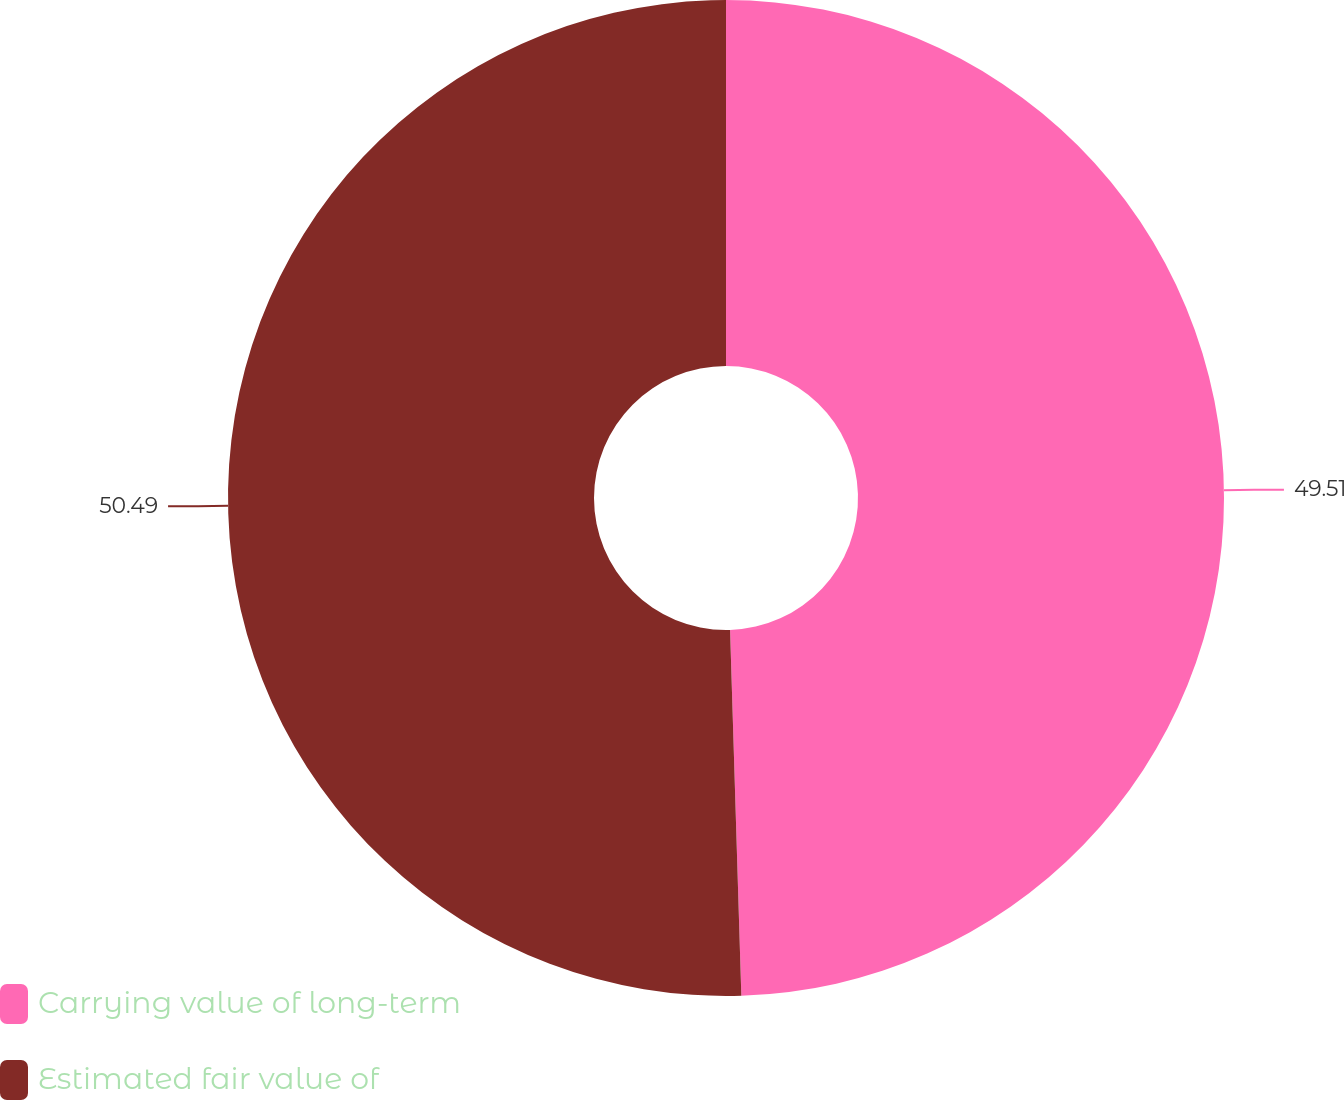<chart> <loc_0><loc_0><loc_500><loc_500><pie_chart><fcel>Carrying value of long-term<fcel>Estimated fair value of<nl><fcel>49.51%<fcel>50.49%<nl></chart> 